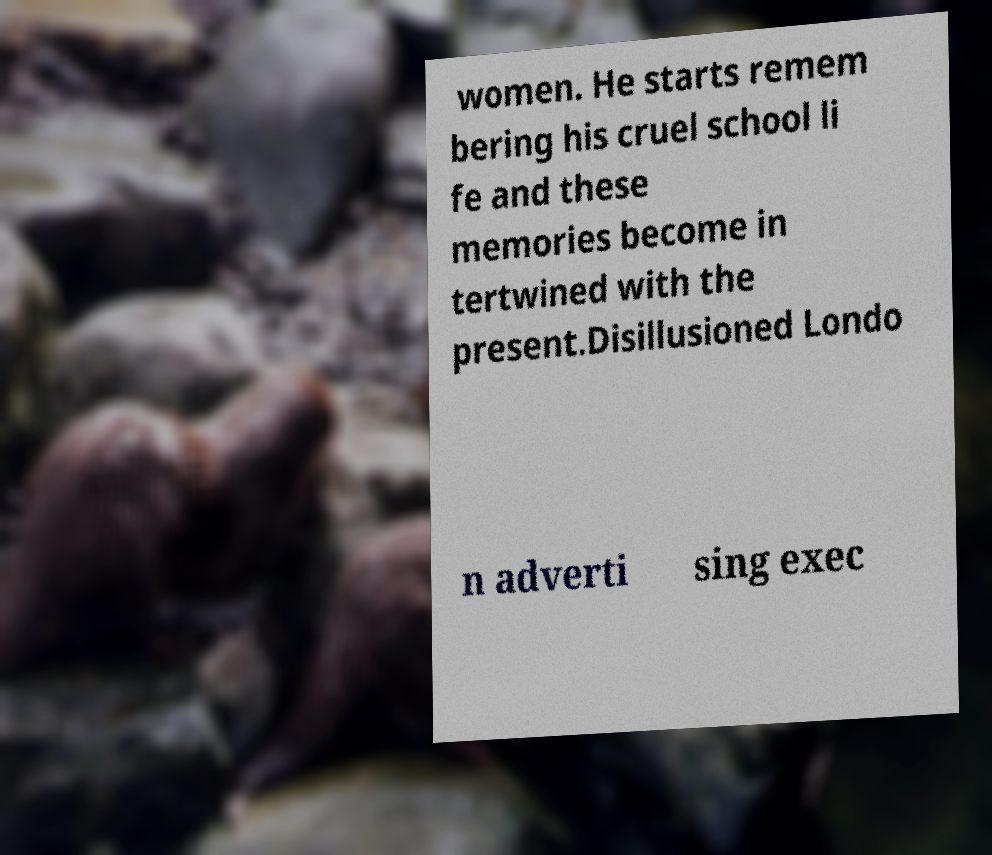What messages or text are displayed in this image? I need them in a readable, typed format. women. He starts remem bering his cruel school li fe and these memories become in tertwined with the present.Disillusioned Londo n adverti sing exec 